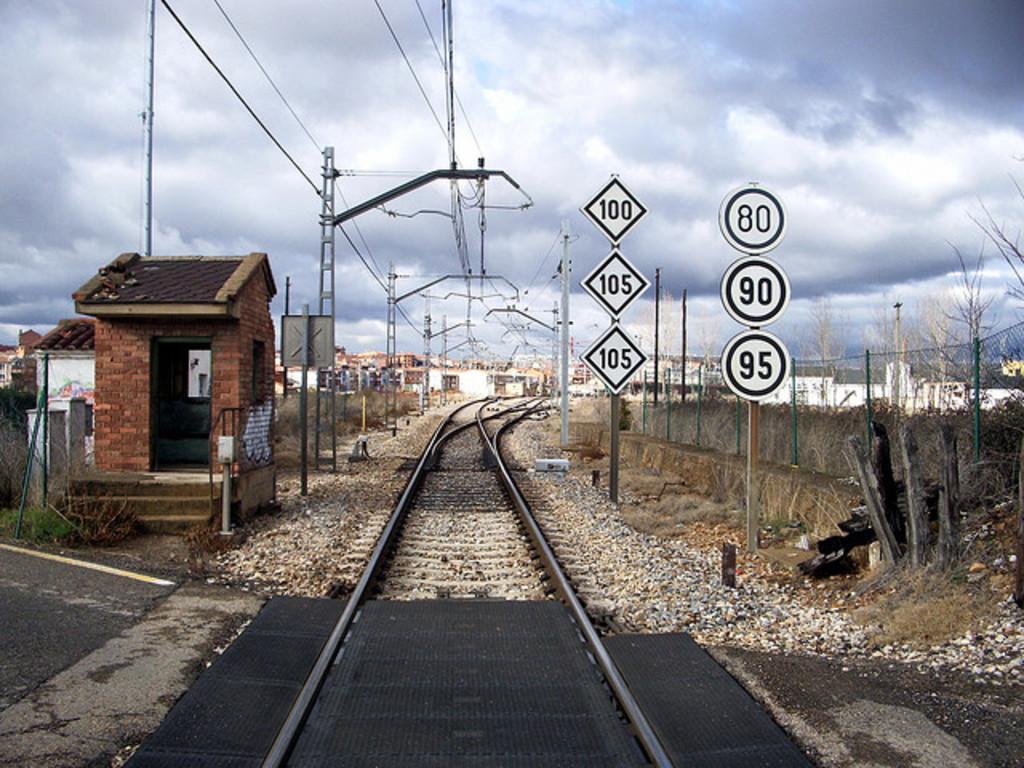In one or two sentences, can you explain what this image depicts? In the center of the image we can see a railway track. On the left there is a shed. We can see poles and there are wires. On the right there are boards and a fence. In the background there are buildings and sky. 